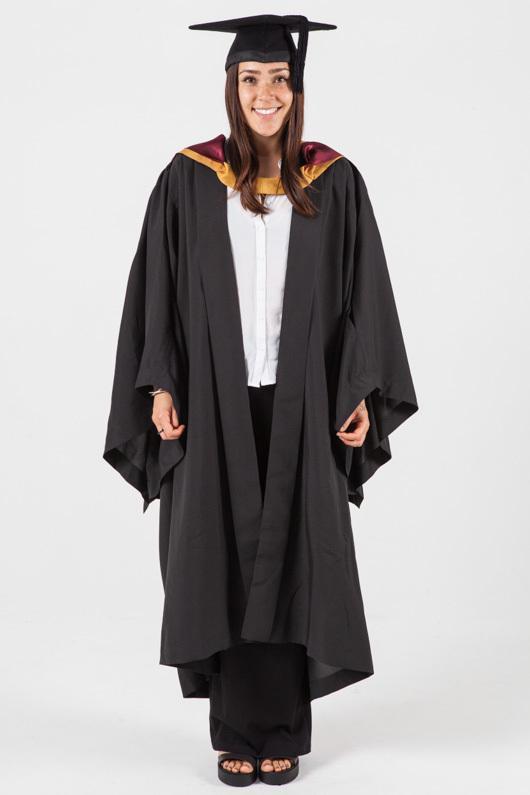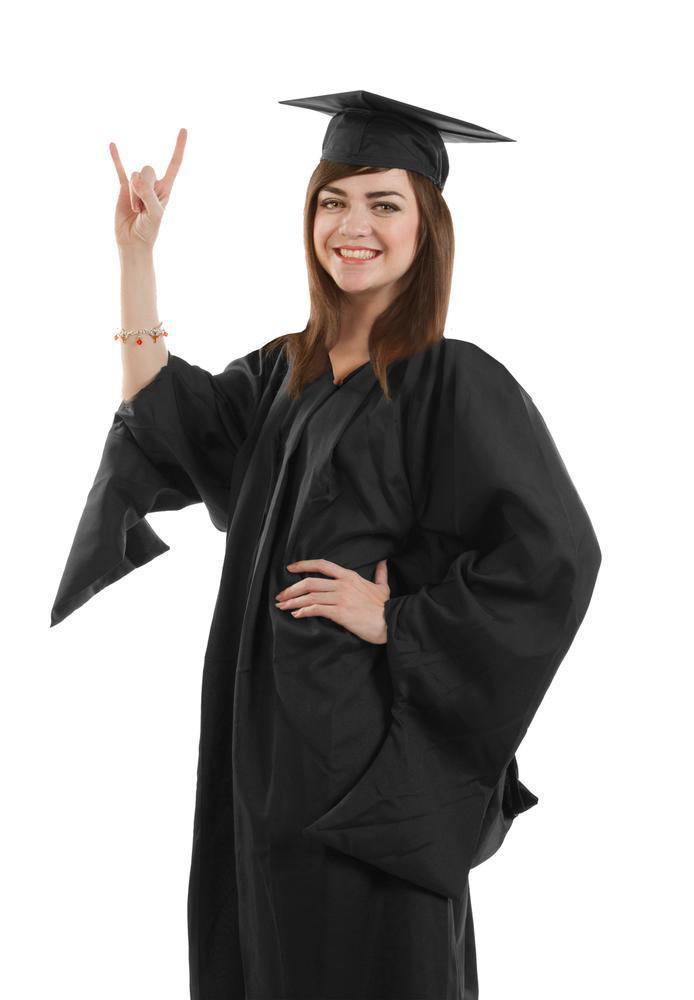The first image is the image on the left, the second image is the image on the right. For the images shown, is this caption "There are two women in graduation clothes facing the camera." true? Answer yes or no. Yes. The first image is the image on the left, the second image is the image on the right. Analyze the images presented: Is the assertion "women facing forward in a cap and gown" valid? Answer yes or no. Yes. 